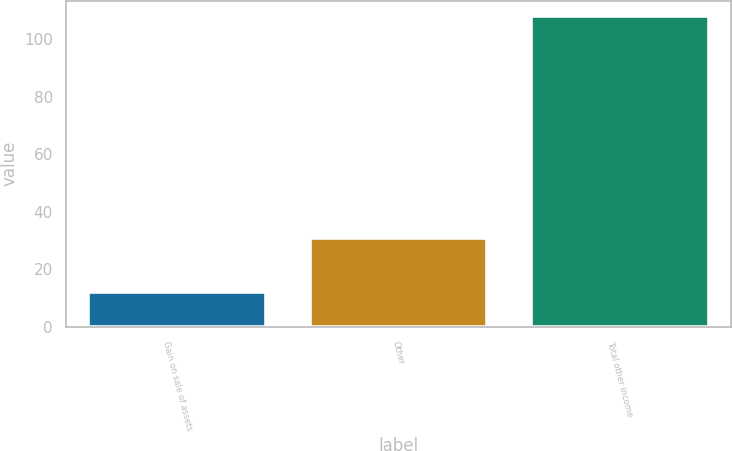Convert chart to OTSL. <chart><loc_0><loc_0><loc_500><loc_500><bar_chart><fcel>Gain on sale of assets<fcel>Other<fcel>Total other income<nl><fcel>12<fcel>31<fcel>108<nl></chart> 